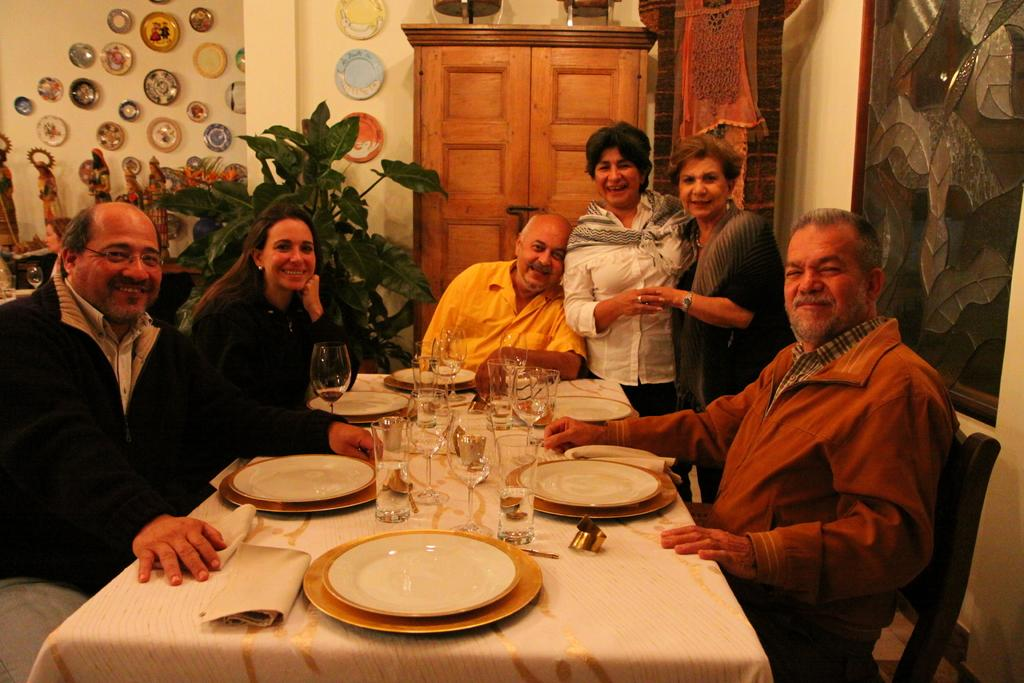What type of structure can be seen in the image? There is a wall in the image. Is there an entrance visible in the image? Yes, there is a door in the image. What are the people in the image doing? The people are sitting on chairs in the image. What is on the table in the image? There are plates, glasses, and a cloth on the table. Can you tell me how many people are swimming in the image? There is no swimming or water activity depicted in the image. What type of mine is visible in the image? There is no mine present in the image. 